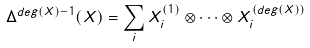<formula> <loc_0><loc_0><loc_500><loc_500>\Delta ^ { d e g ( X ) - 1 } ( X ) = \sum _ { i } X _ { i } ^ { ( 1 ) } \otimes \dots \otimes X _ { i } ^ { ( d e g ( X ) ) }</formula> 